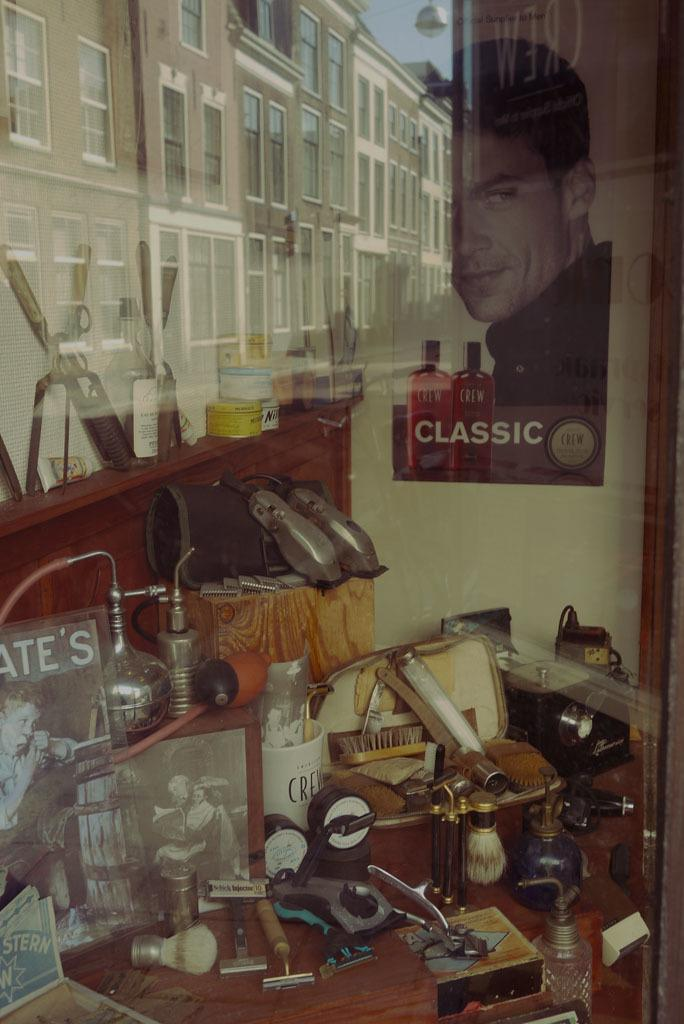<image>
Present a compact description of the photo's key features. A table covered in different knicknacks and tools sits next to a poster of a man with the word Classic written at the bottom. 